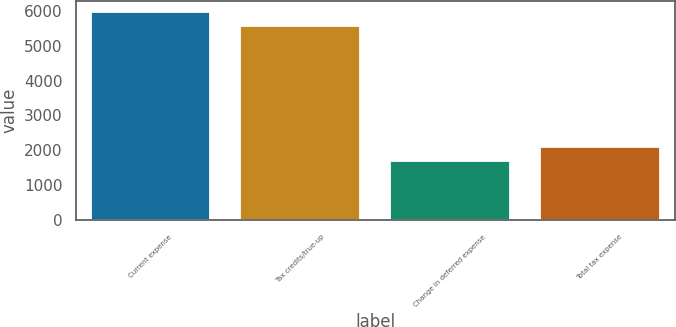<chart> <loc_0><loc_0><loc_500><loc_500><bar_chart><fcel>Current expense<fcel>Tax credits/true-up<fcel>Change in deferred expense<fcel>Total tax expense<nl><fcel>5970.7<fcel>5573<fcel>1700<fcel>2097.7<nl></chart> 